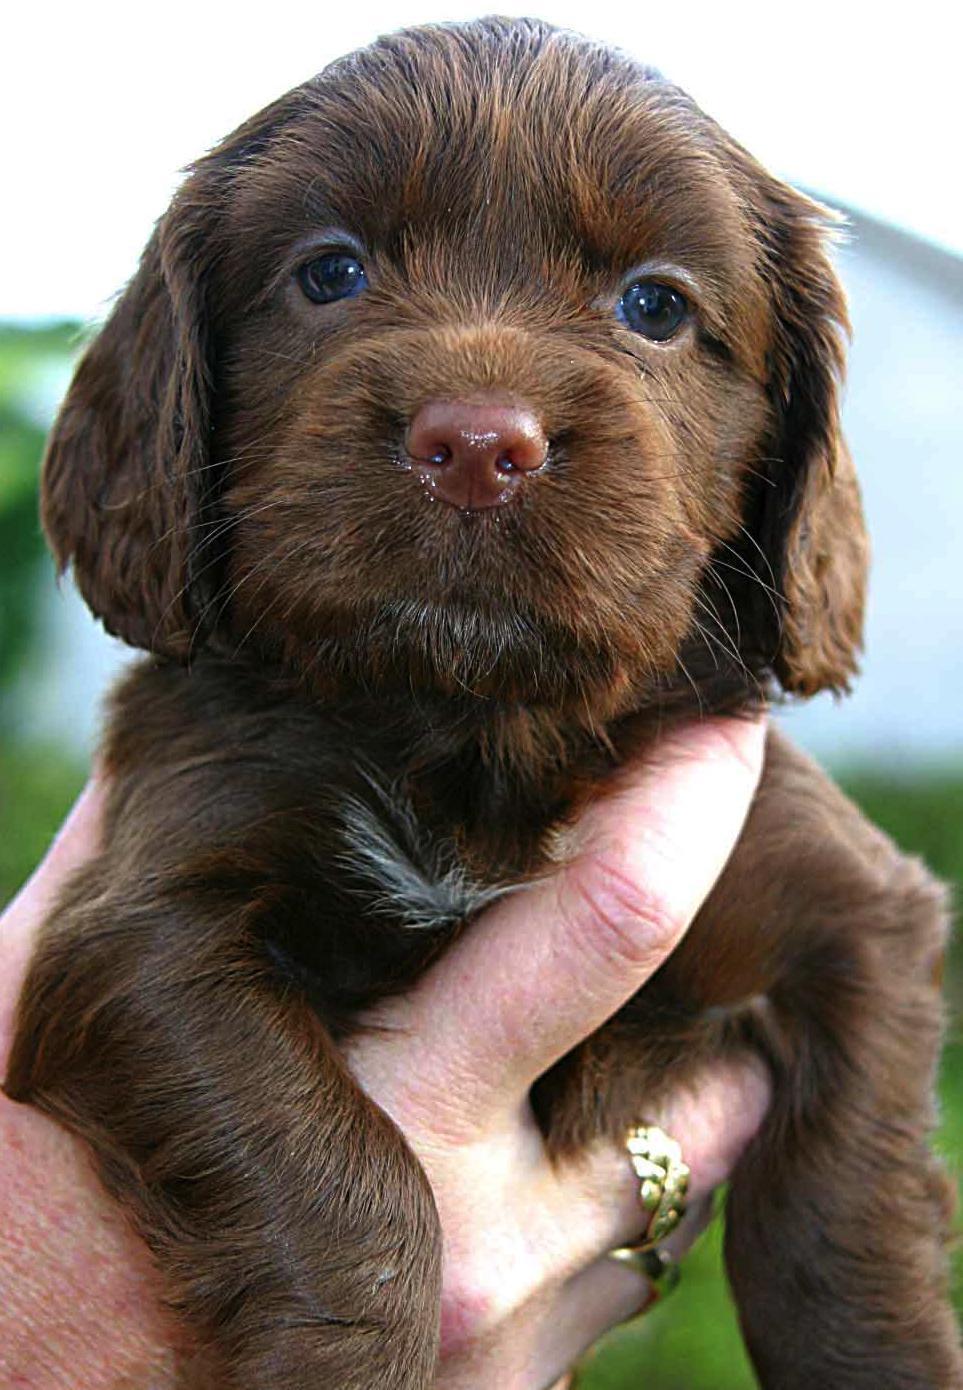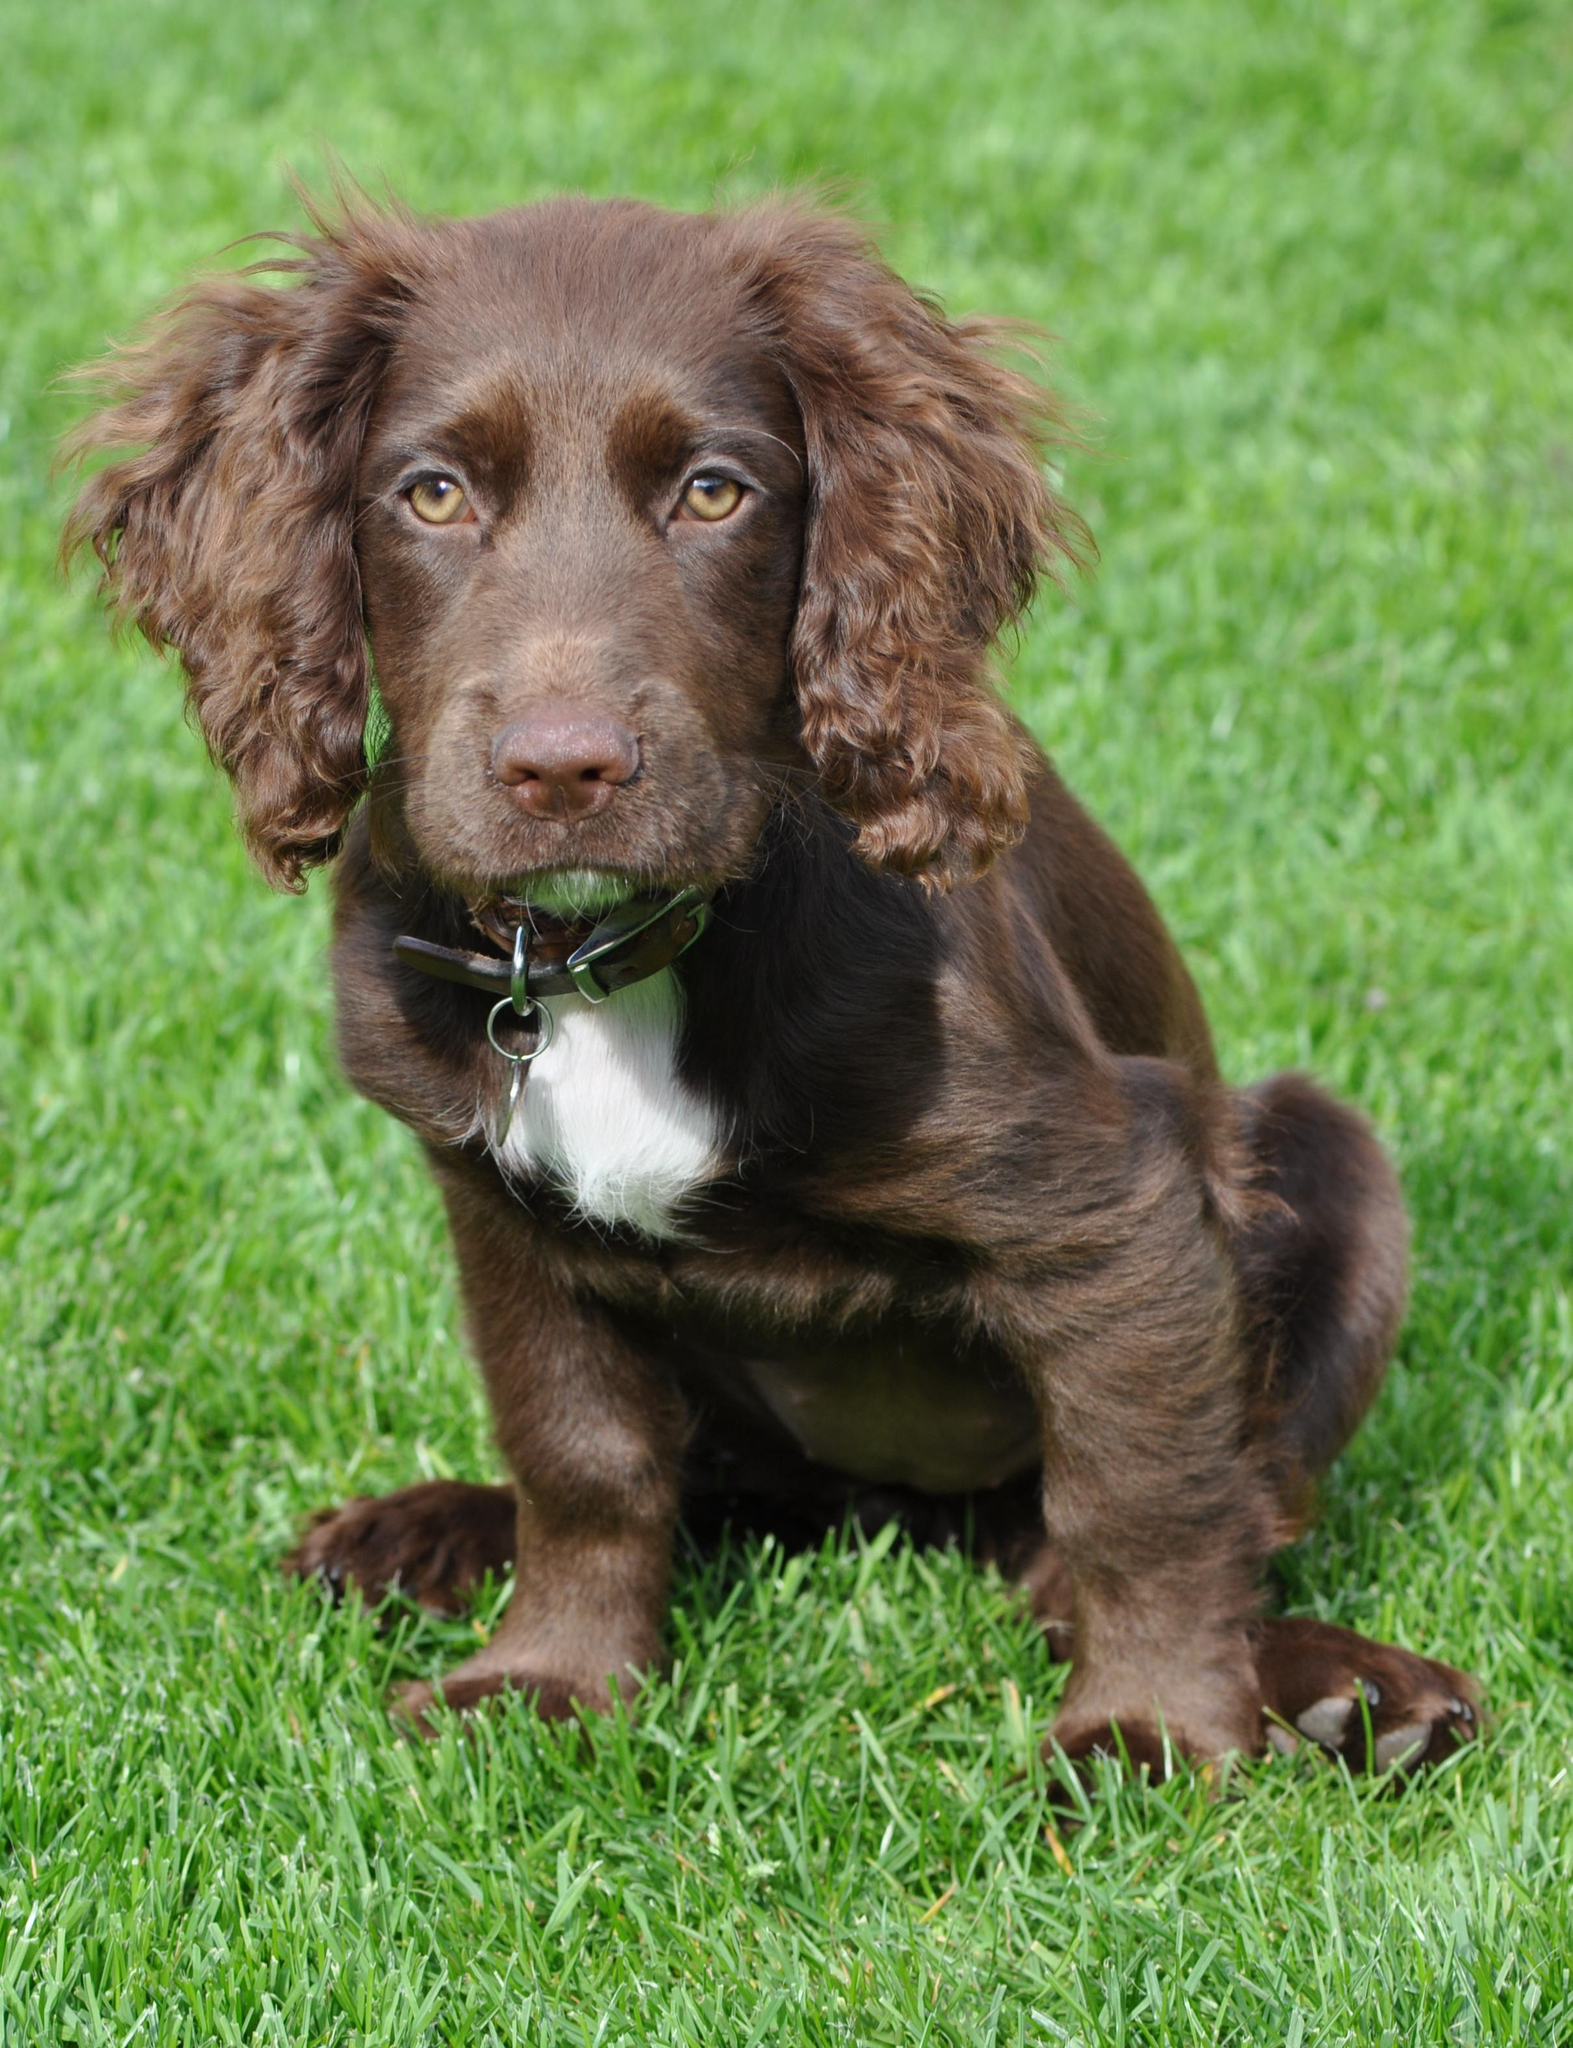The first image is the image on the left, the second image is the image on the right. Analyze the images presented: Is the assertion "A human hand is holding a puppy in the air in one image, and no image contains more than one dog." valid? Answer yes or no. Yes. The first image is the image on the left, the second image is the image on the right. For the images displayed, is the sentence "A person is holding a dog in at least one of the images." factually correct? Answer yes or no. Yes. 